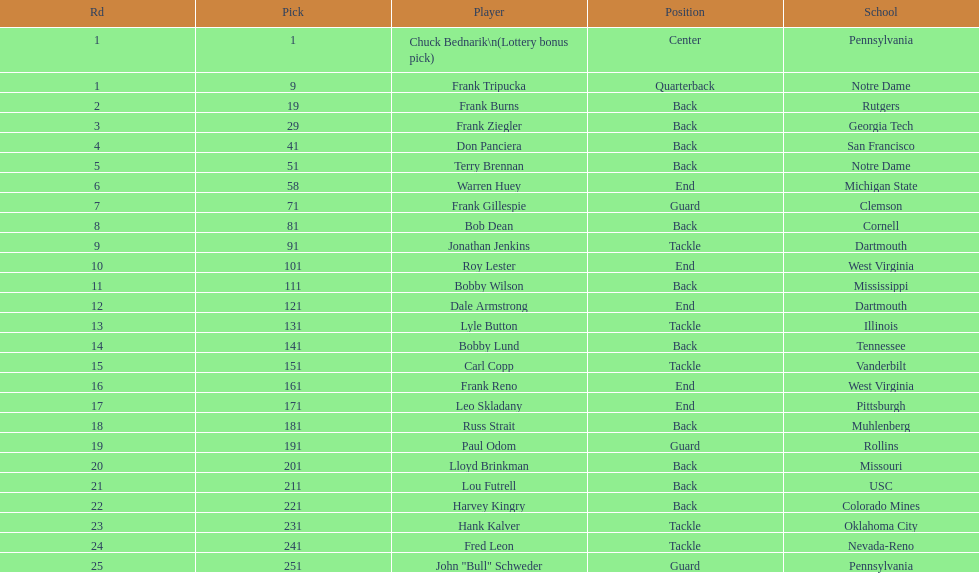What is the number of draft picks that occurred between frank tripucka and dale armstrong? 10. 